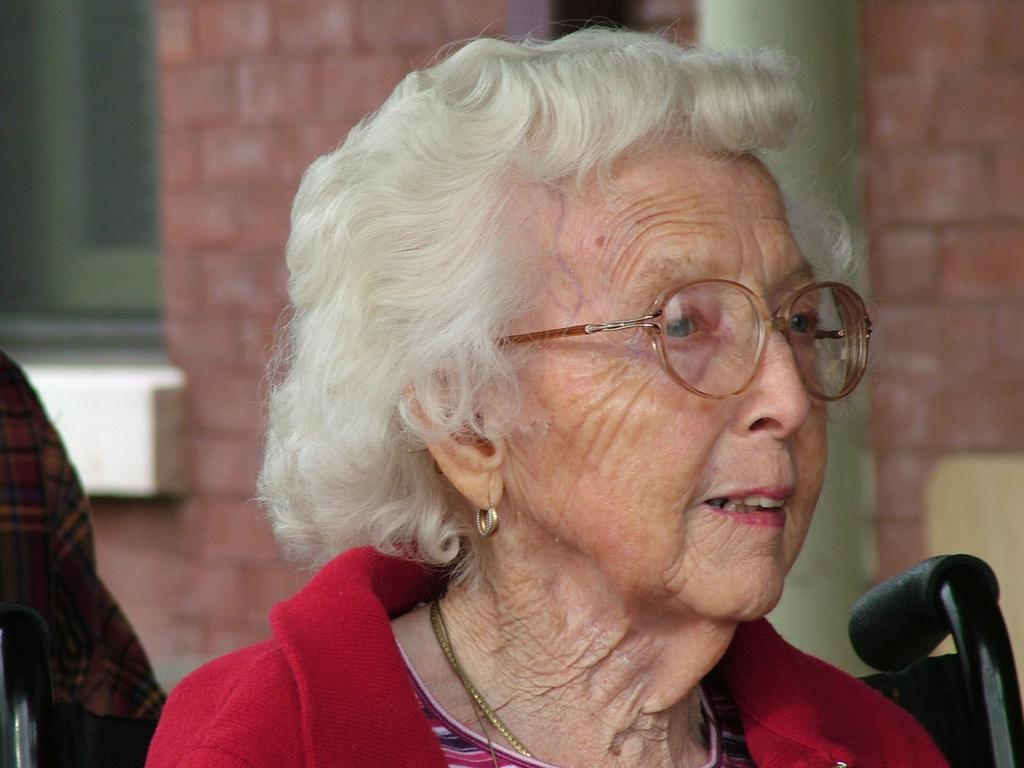Who is the main subject in the image? There is a woman in the image. What is the woman wearing? The woman is wearing a red jacket. What is the woman's position in the image? The woman appears to be sitting in a wheelchair. What can be seen in the background of the image? There is a wall and a window in the background of the image. What type of creature is sitting on the woman's shoulder in the image? There is no creature present on the woman's shoulder in the image. How many cakes are visible on the table in the image? There is no table or cakes present in the image. 